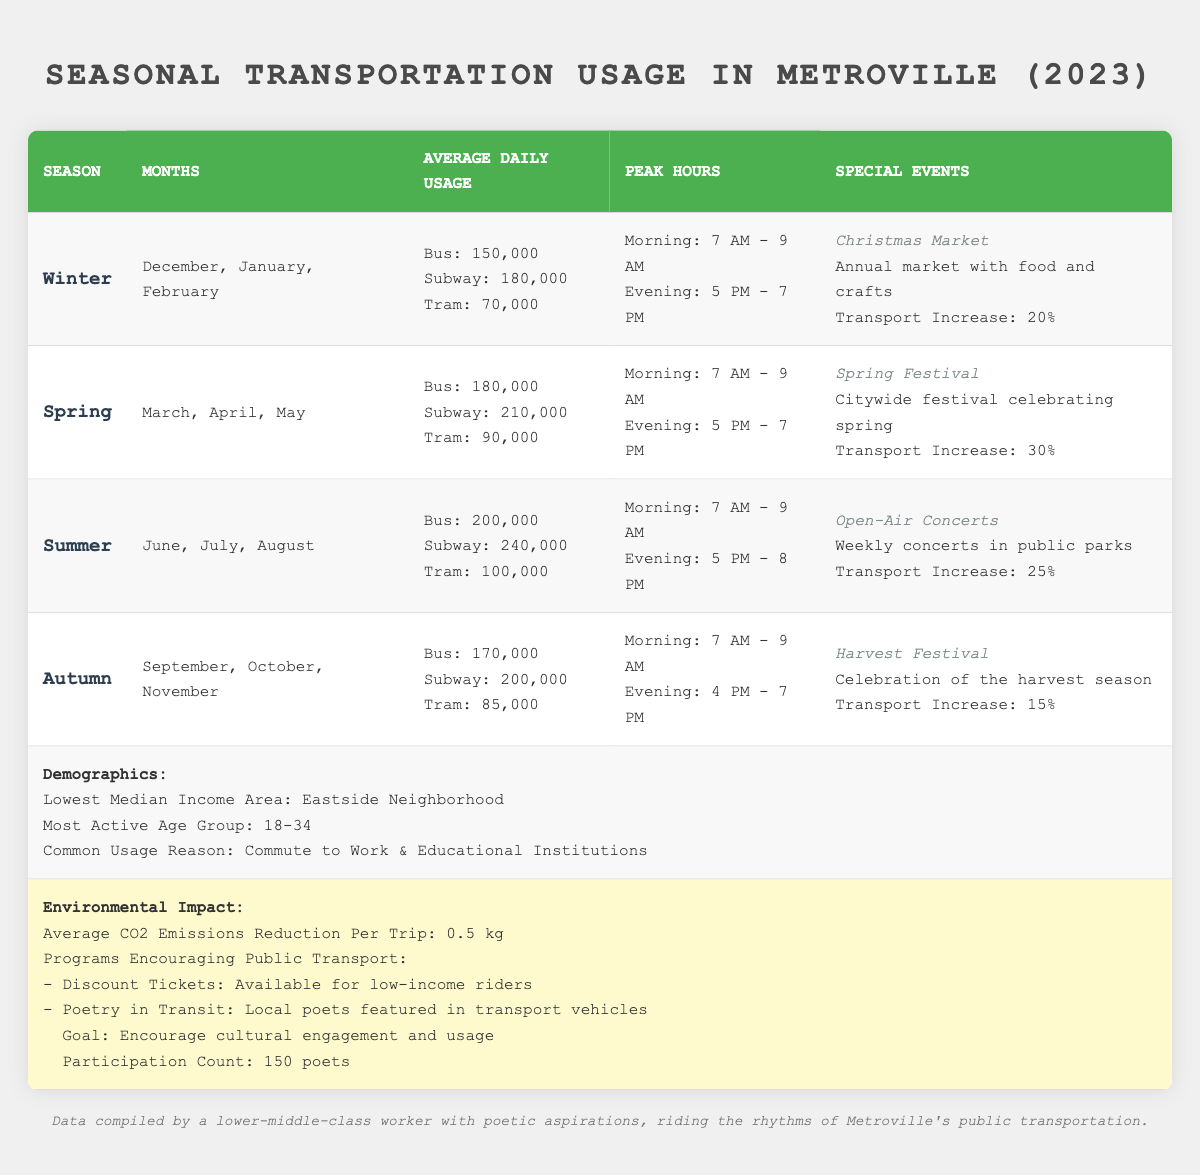What is the average daily usage of the subway in summer? The table states that the average daily usage of the subway during the summer season is 240,000.
Answer: 240,000 In which season is the Christmas Market held? The Christmas Market is listed under the Winter season in the table, specifically held in December, January, and February.
Answer: Winter What is the transport increase percentage during the Spring Festival? The Spring Festival has a transport increase percentage of 30%, which is directly stated in the table.
Answer: 30% Which age group is the most active in using public transportation? According to the demographics section of the table, the most active age group using public transportation is 18-34.
Answer: 18-34 What is the total average daily usage of buses across all seasons? The average daily usage of buses is 150,000 in winter, 180,000 in spring, 200,000 in summer, and 170,000 in autumn. Summing these values gives 150,000 + 180,000 + 200,000 + 170,000 = 700,000. Dividing by 4 seasons gives an average of 700,000 / 4 = 175,000.
Answer: 175,000 Which season has the highest average daily usage of trams? Comparing the average daily usage of trams: Winter (70,000), Spring (90,000), Summer (100,000), and Autumn (85,000), Summer has the highest average usage at 100,000.
Answer: Summer How many poets participated in the 'Poetry in Transit' program? The table specifies that there were 150 poets featured in the 'Poetry in Transit' program as part of the environmental impact initiatives.
Answer: 150 Is there a special event in Autumn that has a transport increase percentage? Yes, the Harvest Festival in Autumn has a transport increase percentage of 15%. This is indicated under the special events section for Autumn in the table.
Answer: Yes What is the average CO2 emissions reduction per trip according to the data? The environmental impact section states that the average CO2 emissions reduction per trip is 0.5 kg, which is explicitly given in the table.
Answer: 0.5 kg Which season has the longest evening peak hour period? For evening peak hours: Winter (5 PM - 7 PM), Spring (5 PM - 7 PM), Summer (5 PM - 8 PM), and Autumn (4 PM - 7 PM). Summer has the longest evening peak hour period lasting from 5 PM to 8 PM.
Answer: Summer 